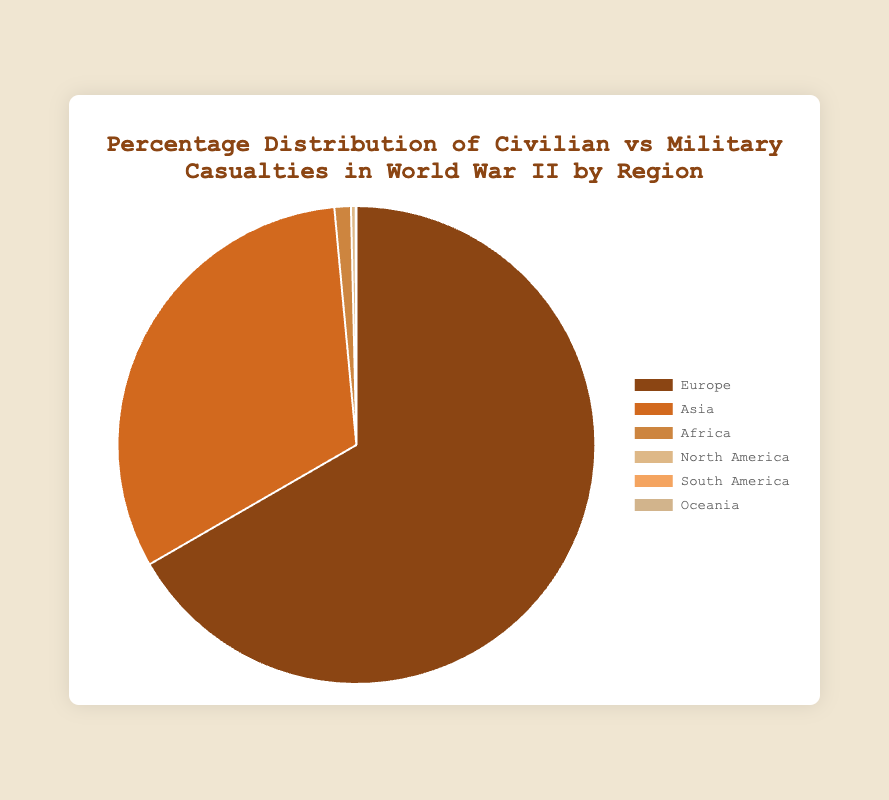Which region had the highest total number of casualties? To determine this, we need to sum the civilian and military casualties for each region. Europe had a total of 60,000,000 (civilian) + 30,000,000 (military) = 90,000,000 casualties, which is the highest among all regions.
Answer: Europe Which region had the lowest total number of casualties? Similarly, sum the numbers for each region. Oceania had a total of just 1,000 (civilian) + 30,000 (military) = 31,000 casualties, the lowest among all regions.
Answer: Oceania What percentage of North America's casualties were military? First, sum North America's total casualties: 6,000 (civilian) + 420,000 (military) = 426,000. Calculate the military percentage: (420,000 / 426,000) * 100 ≈ 98.6%.
Answer: 98.6% Is the percentage of civilian casualties higher in Africa or in Asia? Compare the civilian percentage in each region. Africa's civilian casualties are 500,000 out of a total of 1,500,000. Calculate: (500,000 / 1,500,000) * 100 ≈ 33.3%. Asia's civilian casualties are 35,000,000 out of a total of 43,000,000. Calculate: (35,000,000 / 43,000,000) * 100 ≈ 81.4%. Asia has a higher percentage.
Answer: Asia Which color represents Europe in the pie chart? The colors are mapped sequentially to regions: '#8b4513' to Europe, '#d2691e' to Asia, etc. '#8b4513' is brown.
Answer: Brown By how much does Europe’s total number of casualties exceed Asia's total number of casualties? Find the difference: Europe (90,000,000) - Asia (43,000,000) = 47,000,000.
Answer: 47,000,000 Which region had a higher total number of casualties: North America or South America? Compare totals: North America: 6,000 (civilian) + 420,000 (military) = 426,000; South America: 5,000 (civilian) + 32,000 (military) = 37,000. North America is higher.
Answer: North America What is the ratio of civilian to military casualties in Europe? Divide the numbers: 60,000,000 (civilian) / 30,000,000 (military) = 2.
Answer: 2 How does the distribution of casualties in Oceania compare to that in Africa in terms of percentages? Calculate percentages for both: Oceania - Civilian: (1,000 / 31,000) * 100 ≈ 3.2%, Military: (30,000 / 31,000) * 100 ≈ 96.8%. Africa - Civilian: (500,000 / 1,500,000) * 100 ≈ 33.3%, Military: (1,000,000 / 1,500,000) * 100 ≈ 66.7%.
Answer: Oceania has a higher percentage of military casualties 